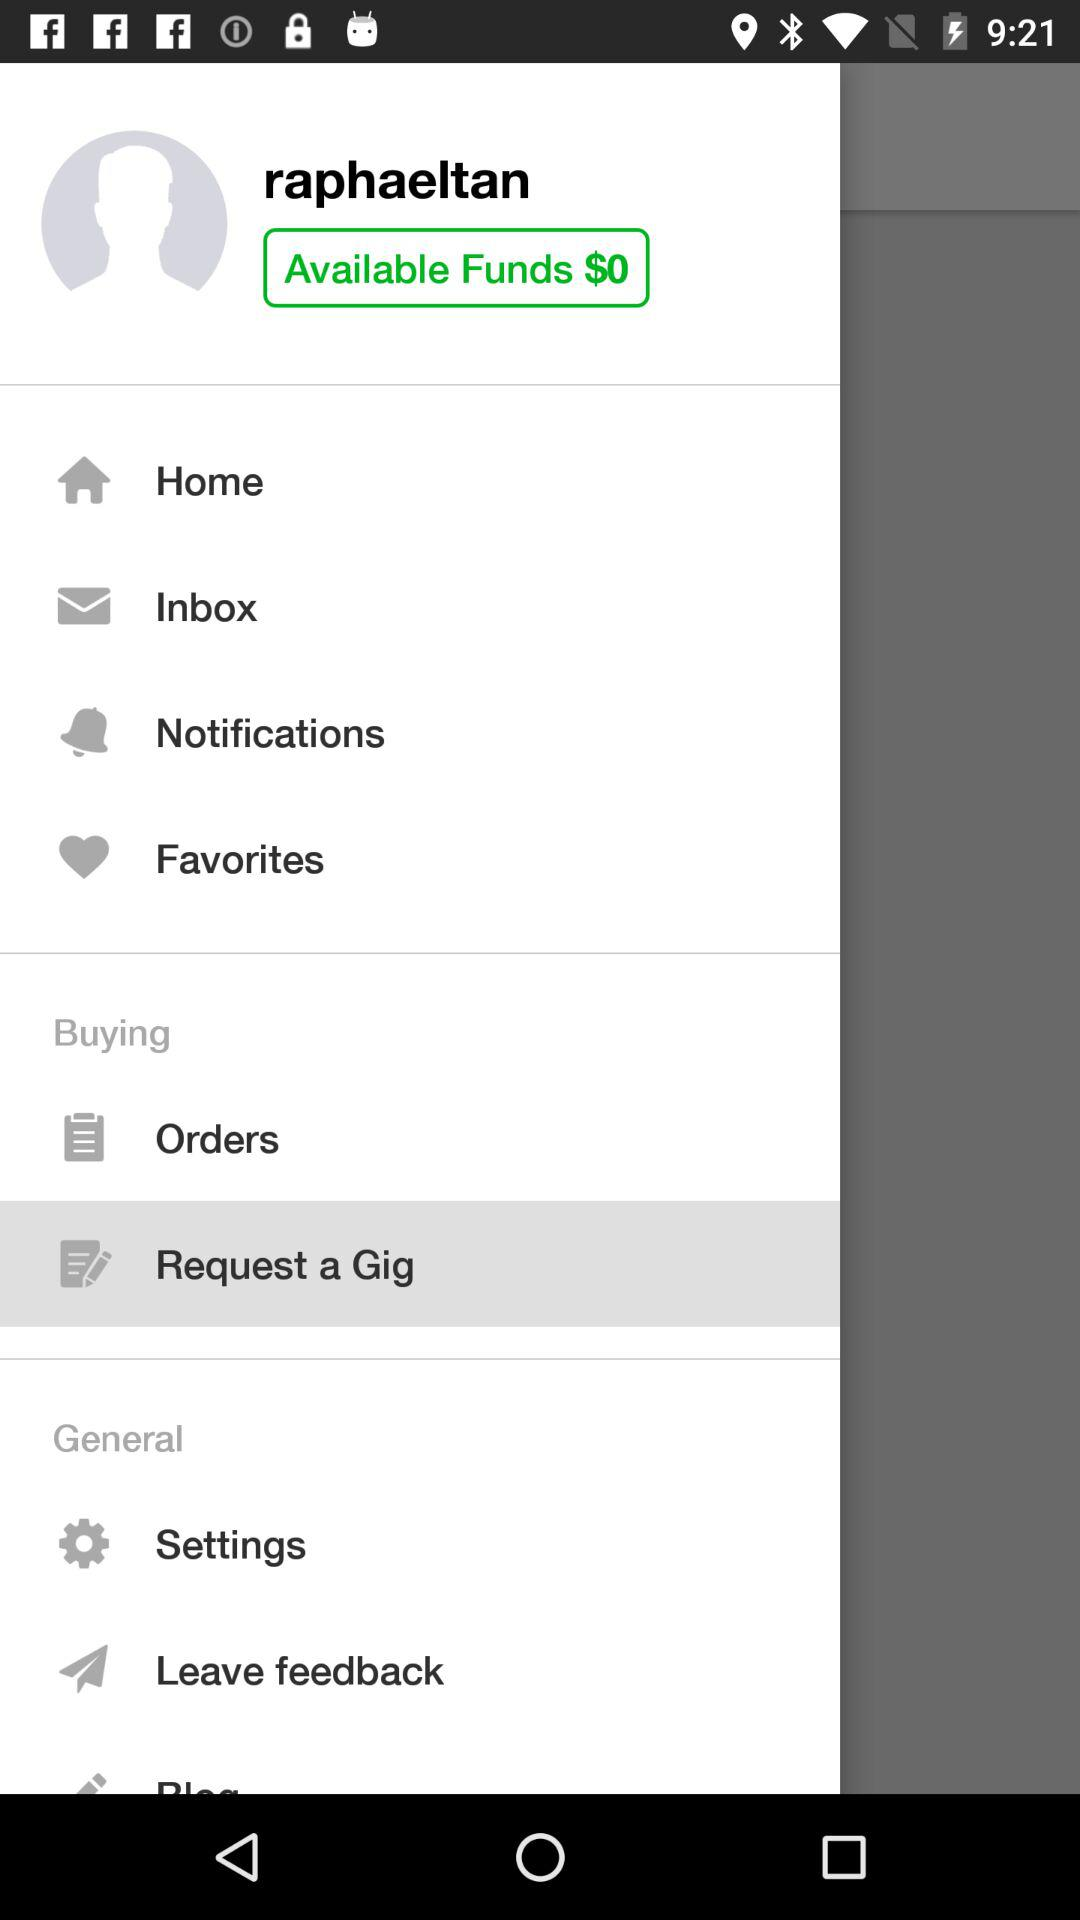How much funds are available? There are no funds available. 